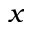Convert formula to latex. <formula><loc_0><loc_0><loc_500><loc_500>x</formula> 